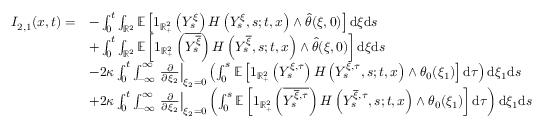<formula> <loc_0><loc_0><loc_500><loc_500>\begin{array} { r l } { I _ { 2 , 1 } ( x , t ) = } & { - \int _ { 0 } ^ { t } \int _ { \mathbb { R } ^ { 2 } } \mathbb { E } \left [ 1 _ { \mathbb { R } _ { + } ^ { 2 } } \left ( Y _ { s } ^ { \xi } \right ) H \left ( Y _ { s } ^ { \xi } , s ; t , x \right ) \wedge \hat { \theta } ( \xi , 0 ) \right ] d \xi d s } \\ & { + \int _ { 0 } ^ { t } \int _ { \mathbb { R } ^ { 2 } } \mathbb { E } \left [ 1 _ { \mathbb { R } _ { + } ^ { 2 } } \left ( \overline { { Y _ { s } ^ { \overline { \xi } } } } \right ) H \left ( Y _ { s } ^ { \overline { \xi } } , s ; t , x \right ) \wedge \hat { \theta } ( \xi , 0 ) \right ] d \xi d s } \\ & { - 2 \kappa \int _ { 0 } ^ { t } \int _ { - \infty } ^ { \infty } \frac { \partial } { \partial \xi _ { 2 } } \right | _ { \xi _ { 2 } = 0 } \left ( \int _ { 0 } ^ { s } \mathbb { E } \left [ 1 _ { \mathbb { R } _ { + } ^ { 2 } } \left ( Y _ { s } ^ { \xi , \tau } \right ) H \left ( Y _ { s } ^ { \xi , \tau } , s ; t , x \right ) \wedge \theta _ { 0 } ( \xi _ { 1 } ) \right ] d \tau \right ) d \xi _ { 1 } d s } \\ & { + 2 \kappa \int _ { 0 } ^ { t } \int _ { - \infty } ^ { \infty } \frac { \partial } { \partial \xi _ { 2 } } \right | _ { \xi _ { 2 } = 0 } \left ( \int _ { 0 } ^ { s } \mathbb { E } \left [ 1 _ { \mathbb { R } _ { + } ^ { 2 } } \left ( \overline { { Y _ { s } ^ { \overline { \xi } , \tau } } } \right ) H \left ( Y _ { s } ^ { \overline { \xi } , \tau } , s ; t , x \right ) \wedge \theta _ { 0 } ( \xi _ { 1 } ) \right ] d \tau \right ) d \xi _ { 1 } d s } \end{array}</formula> 